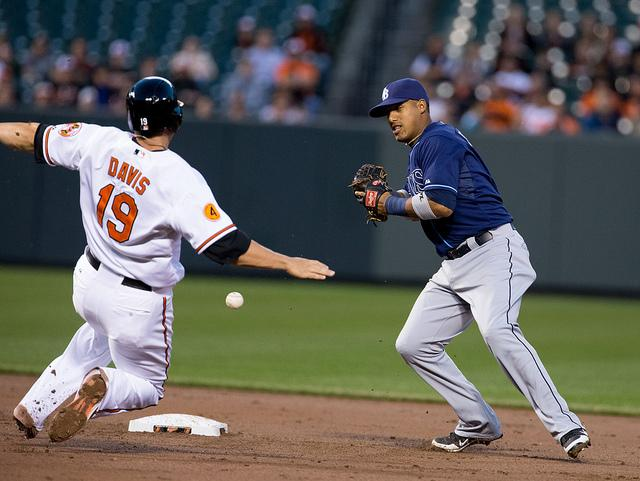What is 19 trying to do?

Choices:
A) sleep
B) touch base
C) get ball
D) avoid player touch base 